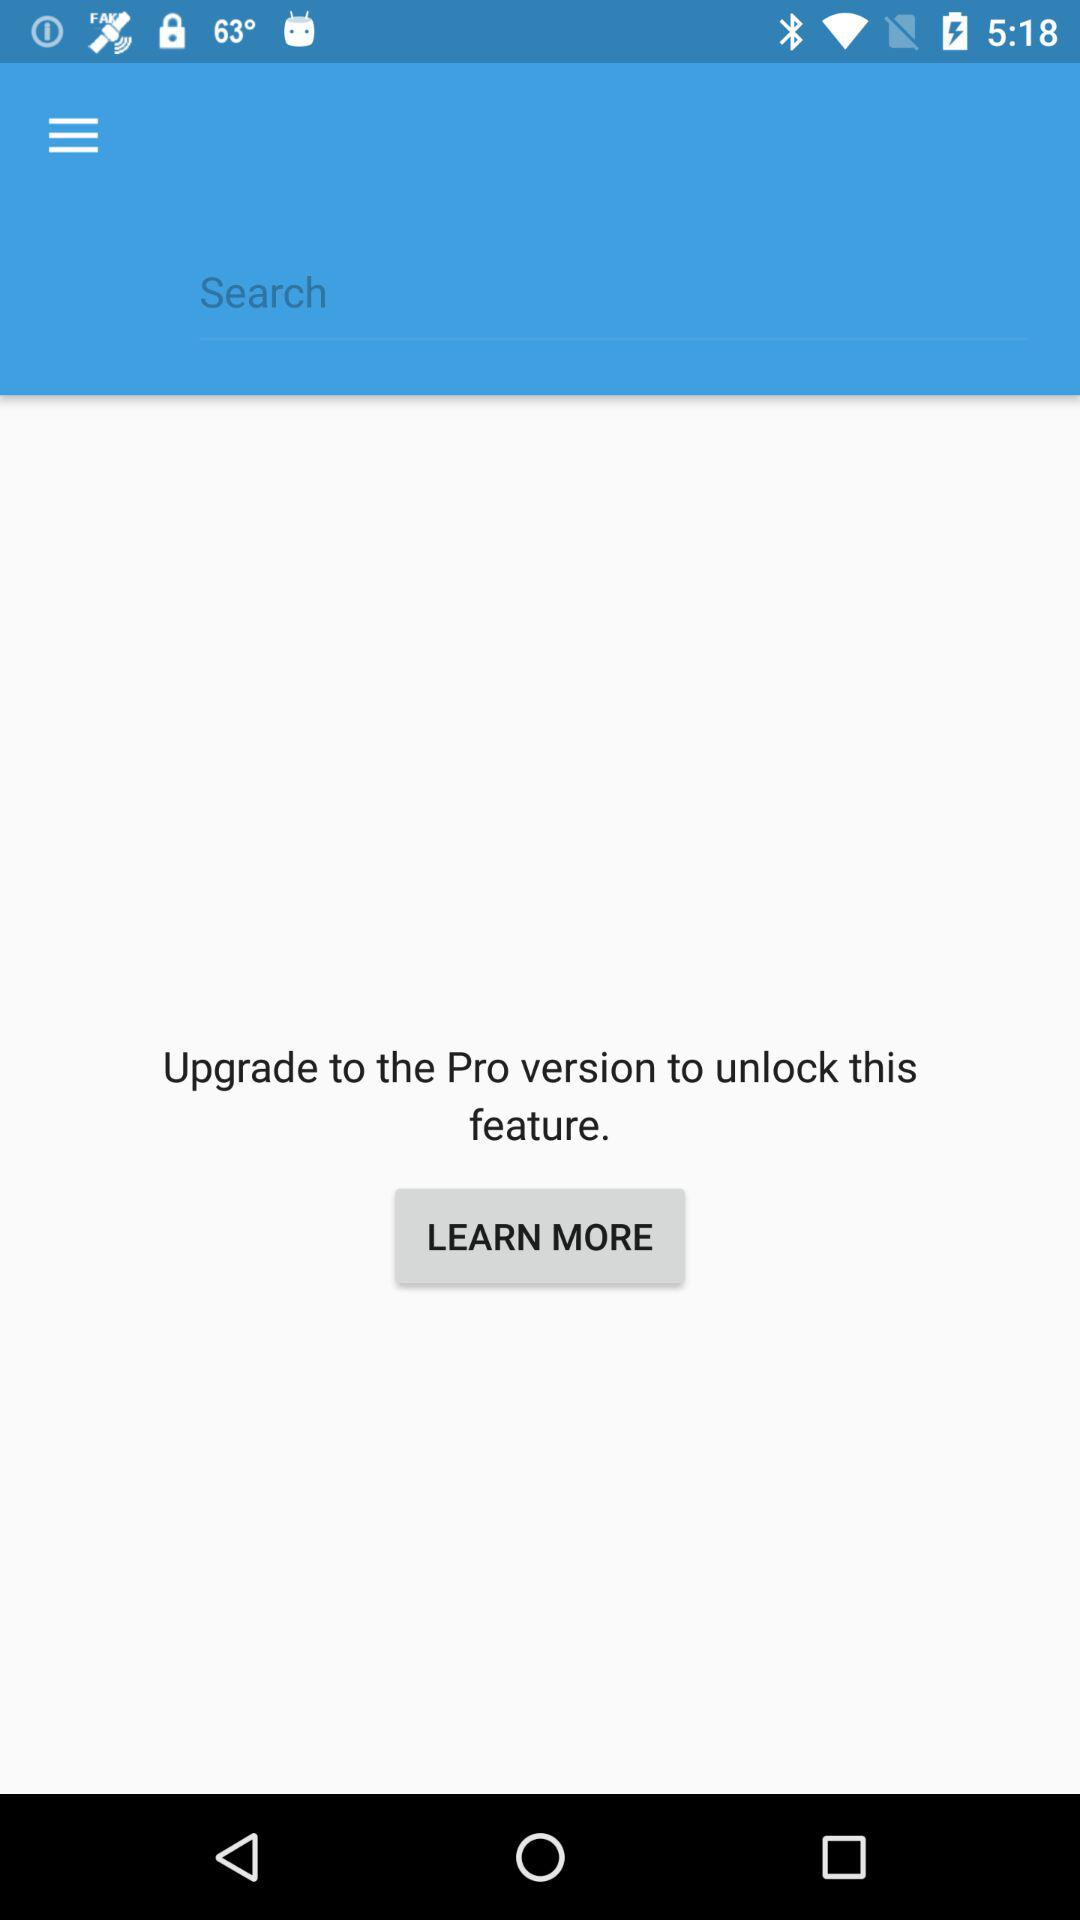What is the condition to unlock the feature? You need to upgrade to the Pro version to unlock the feature. 